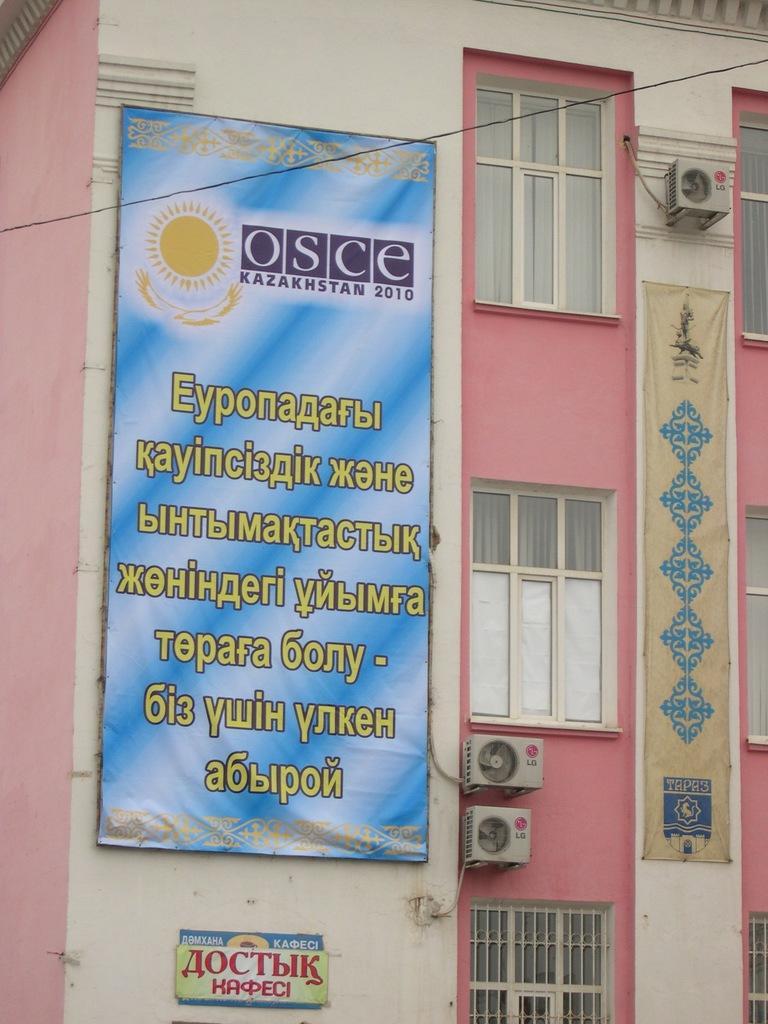Please provide a concise description of this image. This image consists of a building in white and pink color on which there are AC outdoor units and a banner fixed to the wall. 